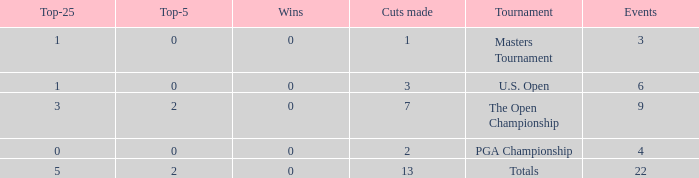What is the average number of cuts made for events with under 4 entries and more than 0 wins? None. 